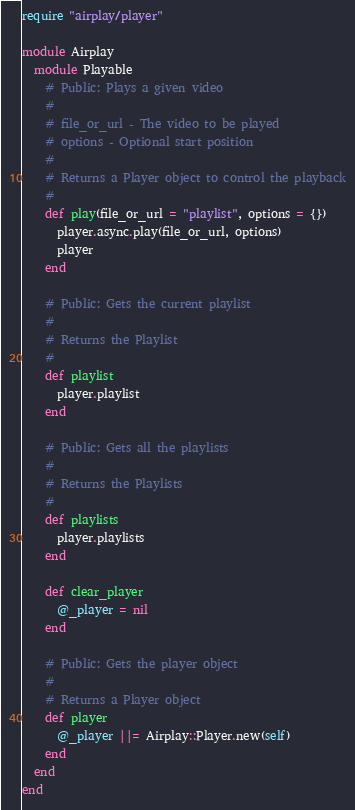Convert code to text. <code><loc_0><loc_0><loc_500><loc_500><_Ruby_>require "airplay/player"

module Airplay
  module Playable
    # Public: Plays a given video
    #
    # file_or_url - The video to be played
    # options - Optional start position
    #
    # Returns a Player object to control the playback
    #
    def play(file_or_url = "playlist", options = {})
      player.async.play(file_or_url, options)
      player
    end

    # Public: Gets the current playlist
    #
    # Returns the Playlist
    #
    def playlist
      player.playlist
    end

    # Public: Gets all the playlists
    #
    # Returns the Playlists
    #
    def playlists
      player.playlists
    end

    def clear_player
      @_player = nil
    end

    # Public: Gets the player object
    #
    # Returns a Player object
    def player
      @_player ||= Airplay::Player.new(self)
    end
  end
end
</code> 